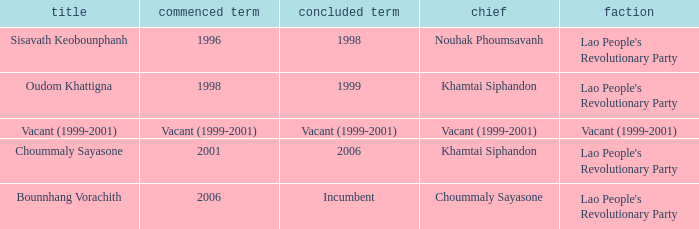What is Party, when Took Office is 1998? Lao People's Revolutionary Party. 